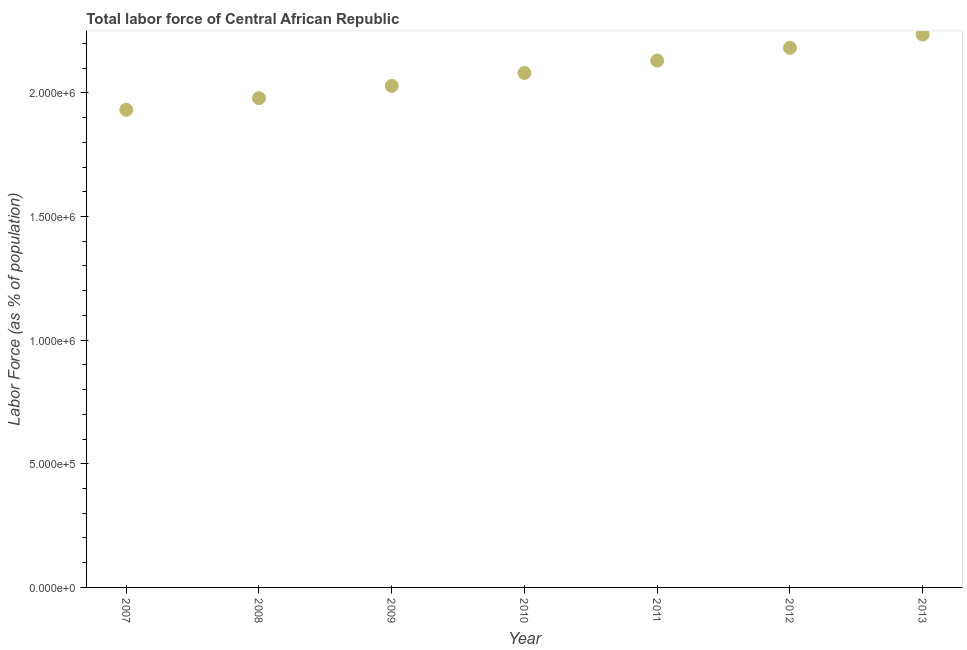What is the total labor force in 2012?
Offer a terse response. 2.18e+06. Across all years, what is the maximum total labor force?
Provide a succinct answer. 2.24e+06. Across all years, what is the minimum total labor force?
Make the answer very short. 1.93e+06. In which year was the total labor force minimum?
Offer a very short reply. 2007. What is the sum of the total labor force?
Give a very brief answer. 1.46e+07. What is the difference between the total labor force in 2008 and 2009?
Your response must be concise. -4.98e+04. What is the average total labor force per year?
Your answer should be compact. 2.08e+06. What is the median total labor force?
Give a very brief answer. 2.08e+06. In how many years, is the total labor force greater than 1400000 %?
Ensure brevity in your answer.  7. Do a majority of the years between 2009 and 2008 (inclusive) have total labor force greater than 200000 %?
Provide a succinct answer. No. What is the ratio of the total labor force in 2009 to that in 2010?
Make the answer very short. 0.97. Is the total labor force in 2011 less than that in 2013?
Provide a succinct answer. Yes. Is the difference between the total labor force in 2010 and 2011 greater than the difference between any two years?
Give a very brief answer. No. What is the difference between the highest and the second highest total labor force?
Give a very brief answer. 5.35e+04. What is the difference between the highest and the lowest total labor force?
Keep it short and to the point. 3.04e+05. Does the total labor force monotonically increase over the years?
Offer a very short reply. Yes. How many years are there in the graph?
Give a very brief answer. 7. What is the difference between two consecutive major ticks on the Y-axis?
Your answer should be very brief. 5.00e+05. Are the values on the major ticks of Y-axis written in scientific E-notation?
Make the answer very short. Yes. Does the graph contain any zero values?
Offer a terse response. No. What is the title of the graph?
Make the answer very short. Total labor force of Central African Republic. What is the label or title of the X-axis?
Provide a succinct answer. Year. What is the label or title of the Y-axis?
Provide a succinct answer. Labor Force (as % of population). What is the Labor Force (as % of population) in 2007?
Your answer should be compact. 1.93e+06. What is the Labor Force (as % of population) in 2008?
Provide a succinct answer. 1.98e+06. What is the Labor Force (as % of population) in 2009?
Provide a short and direct response. 2.03e+06. What is the Labor Force (as % of population) in 2010?
Your response must be concise. 2.08e+06. What is the Labor Force (as % of population) in 2011?
Give a very brief answer. 2.13e+06. What is the Labor Force (as % of population) in 2012?
Provide a succinct answer. 2.18e+06. What is the Labor Force (as % of population) in 2013?
Provide a short and direct response. 2.24e+06. What is the difference between the Labor Force (as % of population) in 2007 and 2008?
Provide a short and direct response. -4.70e+04. What is the difference between the Labor Force (as % of population) in 2007 and 2009?
Keep it short and to the point. -9.67e+04. What is the difference between the Labor Force (as % of population) in 2007 and 2010?
Make the answer very short. -1.49e+05. What is the difference between the Labor Force (as % of population) in 2007 and 2011?
Provide a short and direct response. -1.99e+05. What is the difference between the Labor Force (as % of population) in 2007 and 2012?
Keep it short and to the point. -2.51e+05. What is the difference between the Labor Force (as % of population) in 2007 and 2013?
Your answer should be very brief. -3.04e+05. What is the difference between the Labor Force (as % of population) in 2008 and 2009?
Your response must be concise. -4.98e+04. What is the difference between the Labor Force (as % of population) in 2008 and 2010?
Offer a terse response. -1.02e+05. What is the difference between the Labor Force (as % of population) in 2008 and 2011?
Give a very brief answer. -1.52e+05. What is the difference between the Labor Force (as % of population) in 2008 and 2012?
Offer a terse response. -2.04e+05. What is the difference between the Labor Force (as % of population) in 2008 and 2013?
Your answer should be compact. -2.57e+05. What is the difference between the Labor Force (as % of population) in 2009 and 2010?
Make the answer very short. -5.22e+04. What is the difference between the Labor Force (as % of population) in 2009 and 2011?
Your answer should be compact. -1.02e+05. What is the difference between the Labor Force (as % of population) in 2009 and 2012?
Provide a succinct answer. -1.54e+05. What is the difference between the Labor Force (as % of population) in 2009 and 2013?
Your answer should be very brief. -2.07e+05. What is the difference between the Labor Force (as % of population) in 2010 and 2011?
Your answer should be compact. -5.00e+04. What is the difference between the Labor Force (as % of population) in 2010 and 2012?
Your answer should be compact. -1.02e+05. What is the difference between the Labor Force (as % of population) in 2010 and 2013?
Your response must be concise. -1.55e+05. What is the difference between the Labor Force (as % of population) in 2011 and 2012?
Provide a succinct answer. -5.16e+04. What is the difference between the Labor Force (as % of population) in 2011 and 2013?
Give a very brief answer. -1.05e+05. What is the difference between the Labor Force (as % of population) in 2012 and 2013?
Ensure brevity in your answer.  -5.35e+04. What is the ratio of the Labor Force (as % of population) in 2007 to that in 2010?
Keep it short and to the point. 0.93. What is the ratio of the Labor Force (as % of population) in 2007 to that in 2011?
Make the answer very short. 0.91. What is the ratio of the Labor Force (as % of population) in 2007 to that in 2012?
Make the answer very short. 0.89. What is the ratio of the Labor Force (as % of population) in 2007 to that in 2013?
Ensure brevity in your answer.  0.86. What is the ratio of the Labor Force (as % of population) in 2008 to that in 2010?
Provide a succinct answer. 0.95. What is the ratio of the Labor Force (as % of population) in 2008 to that in 2011?
Your answer should be very brief. 0.93. What is the ratio of the Labor Force (as % of population) in 2008 to that in 2012?
Give a very brief answer. 0.91. What is the ratio of the Labor Force (as % of population) in 2008 to that in 2013?
Keep it short and to the point. 0.89. What is the ratio of the Labor Force (as % of population) in 2009 to that in 2010?
Keep it short and to the point. 0.97. What is the ratio of the Labor Force (as % of population) in 2009 to that in 2011?
Make the answer very short. 0.95. What is the ratio of the Labor Force (as % of population) in 2009 to that in 2012?
Offer a terse response. 0.93. What is the ratio of the Labor Force (as % of population) in 2009 to that in 2013?
Your response must be concise. 0.91. What is the ratio of the Labor Force (as % of population) in 2010 to that in 2012?
Your answer should be very brief. 0.95. What is the ratio of the Labor Force (as % of population) in 2011 to that in 2012?
Your response must be concise. 0.98. What is the ratio of the Labor Force (as % of population) in 2011 to that in 2013?
Make the answer very short. 0.95. What is the ratio of the Labor Force (as % of population) in 2012 to that in 2013?
Ensure brevity in your answer.  0.98. 